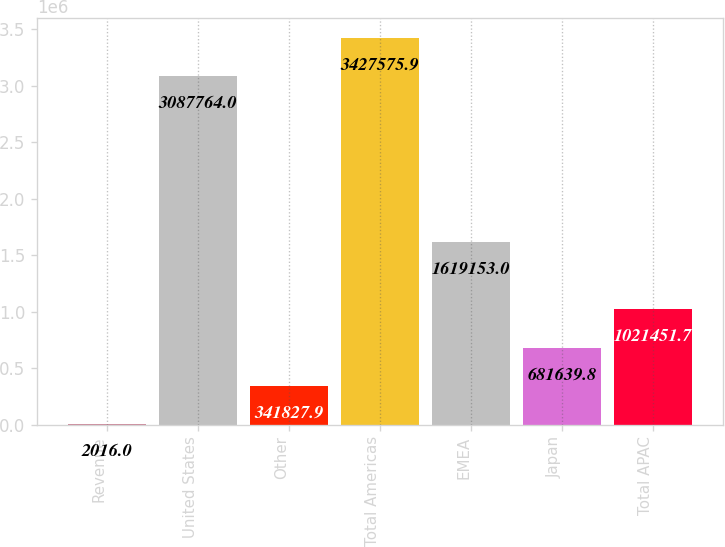Convert chart. <chart><loc_0><loc_0><loc_500><loc_500><bar_chart><fcel>Revenue<fcel>United States<fcel>Other<fcel>Total Americas<fcel>EMEA<fcel>Japan<fcel>Total APAC<nl><fcel>2016<fcel>3.08776e+06<fcel>341828<fcel>3.42758e+06<fcel>1.61915e+06<fcel>681640<fcel>1.02145e+06<nl></chart> 